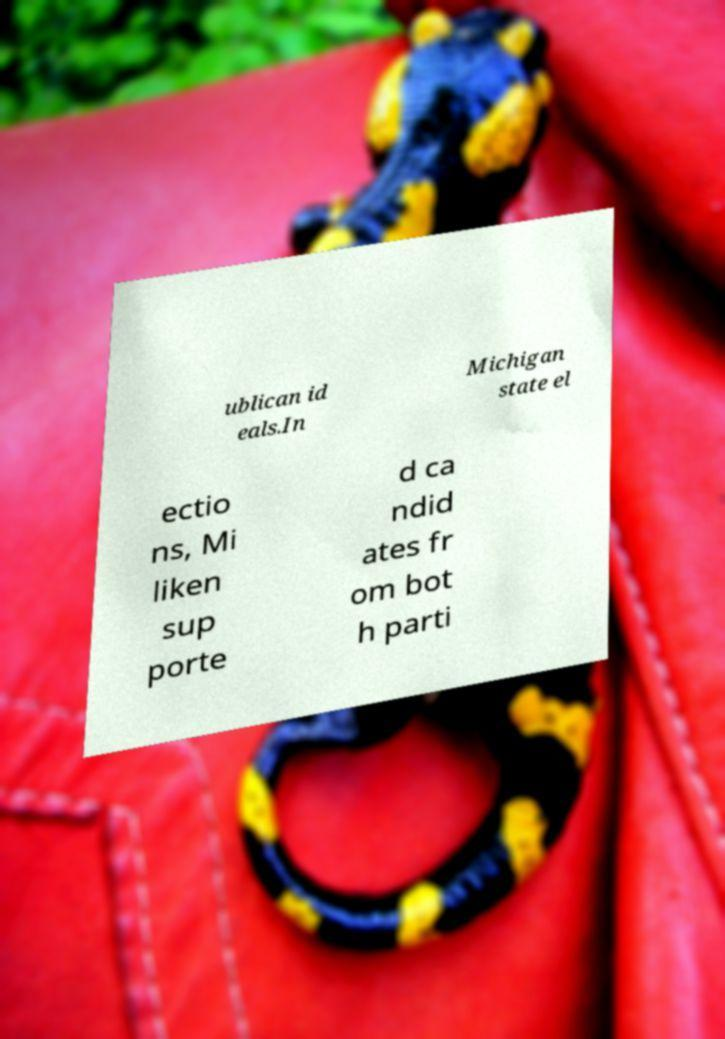Could you assist in decoding the text presented in this image and type it out clearly? ublican id eals.In Michigan state el ectio ns, Mi liken sup porte d ca ndid ates fr om bot h parti 